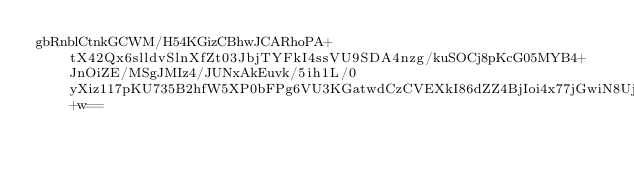<code> <loc_0><loc_0><loc_500><loc_500><_SML_>gbRnblCtnkGCWM/H54KGizCBhwJCARhoPA+tX42Qx6slldvSlnXfZt03JbjTYFkI4ssVU9SDA4nzg/kuSOCj8pKcG05MYB4+JnOiZE/MSgJMIz4/JUNxAkEuvk/5ih1L/0yXiz117pKU735B2hfW5XP0bFPg6VU3KGatwdCzCVEXkI86dZZ4BjIoi4x77jGwiN8UjnxEevY9+w==</code> 